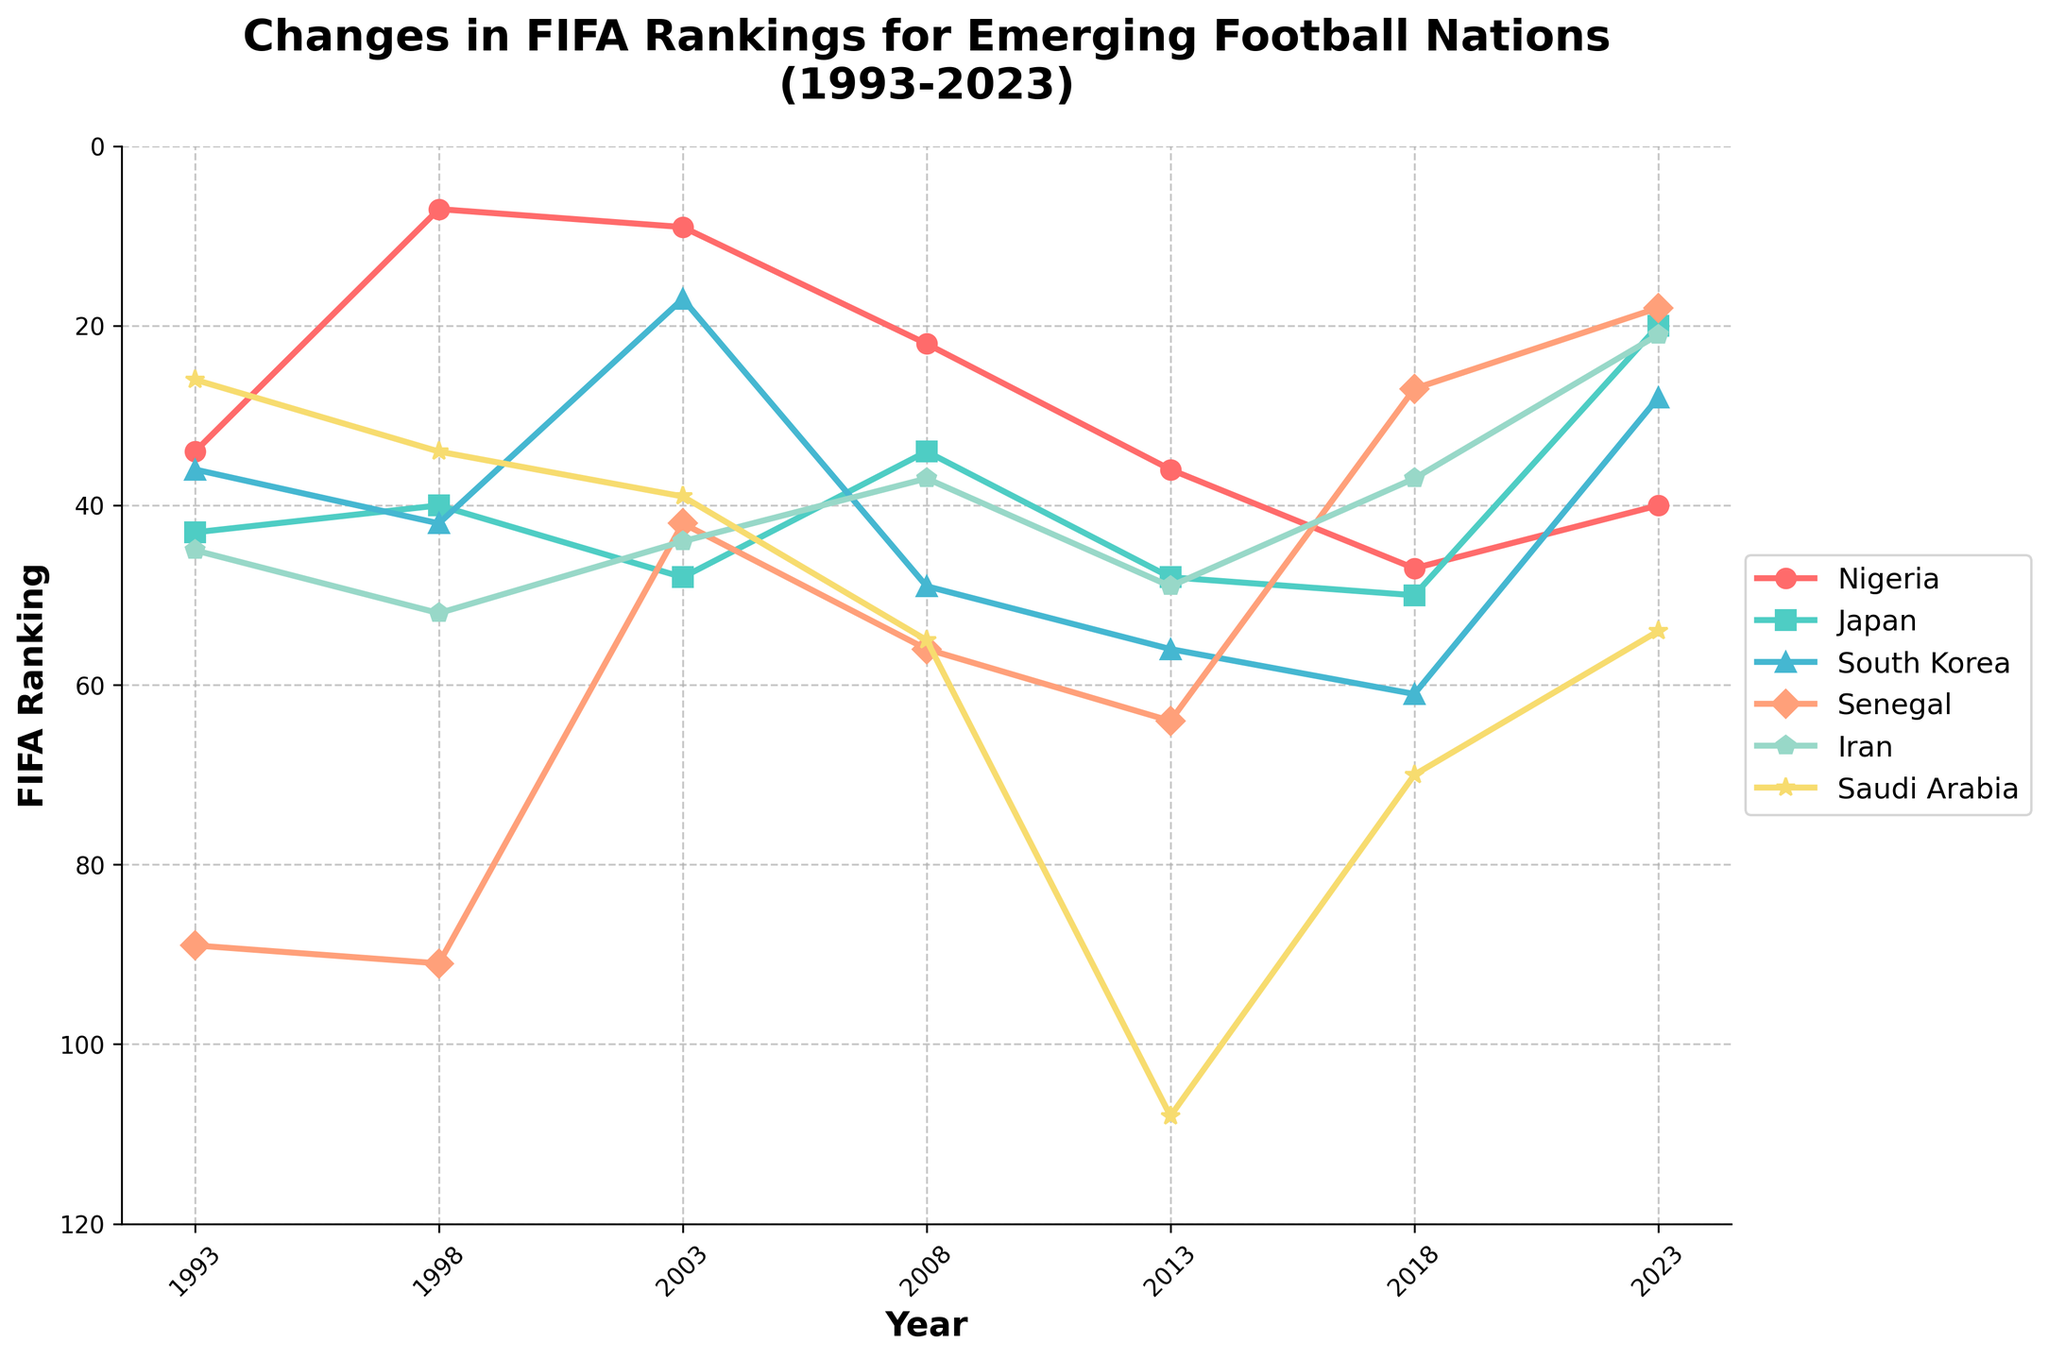Which country has shown the most improvement in FIFA rankings from 1993 to 2023? To determine the most improved country, compare the rankings from 1993 and 2023 for each country. Nigeria improved from 34 to 40 (not an improvement), Japan from 43 to 20, South Korea from 36 to 28, Senegal from 89 to 18, Iran from 45 to 21, and Saudi Arabia from 26 to 54 (not an improvement). The largest improvement is seen in Senegal, from 89 to 18.
Answer: Senegal Which country had the highest FIFA ranking in 1998? Review the ranking values for each country in 1998. Nigeria had the highest ranking of 7.
Answer: Nigeria What is the average FIFA ranking for South Korea over the given period (1993-2023)? To calculate the average, sum all FIFA rankings for South Korea from 1993 to 2023 (36 + 42 + 17 + 49 + 56 + 61 + 28) = 289 and then divide by the number of data points (7). So, 289/7 = 41.29.
Answer: 41.29 Which country experienced the steepest decline in FIFA ranking from 1998 to 2013? Compare the rankings of each country between 1998 and 2013 to determine the change. Nigeria changed from 7 to 36, Japan from 40 to 48, South Korea from 42 to 56, Senegal from 91 to 64, Iran from 52 to 49, and Saudi Arabia from 34 to 108. Saudi Arabia had the steepest decline.
Answer: Saudi Arabia In which year did Iran have its best FIFA ranking according to the figure? Check Iran's rankings across all years. Iran's best ranking is 21 in 2023.
Answer: 2023 How did Japan's ranking change between 2008 and 2023? To find Japan's rank change, subtract the 2023 ranking from the 2008 ranking (34 - 20 = 14). Since 14 is positive, Japan has improved by 14 ranks.
Answer: Improved by 14 ranks Compare the FIFA rankings of Nigeria and Senegal in 2023. Who has the better ranking and by how many positions? In 2023, Nigeria's ranking is 40, and Senegal's is 18. Senegal has the better ranking by (40 - 18) = 22 positions.
Answer: Senegal by 22 positions Which country showed a consistent improvement in ranking, with no drops, from 1993 to 2023? Review the ranking trends for each country. Japan's rankings (43, 40, 48, 34, 48, 50, 20) show consistent improvement without drops.
Answer: Japan How many times did Saudi Arabia's ranking drop compared to the previous recorded period? Track the changes in Saudi Arabia's rankings from one period to the next: 26 to 34 (down), 34 to 39 (down), 39 to 55 (down), 55 to 108 (down), 108 to 70 (up), 70 to 54 (up). Drops occurred 4 times.
Answer: 4 times 